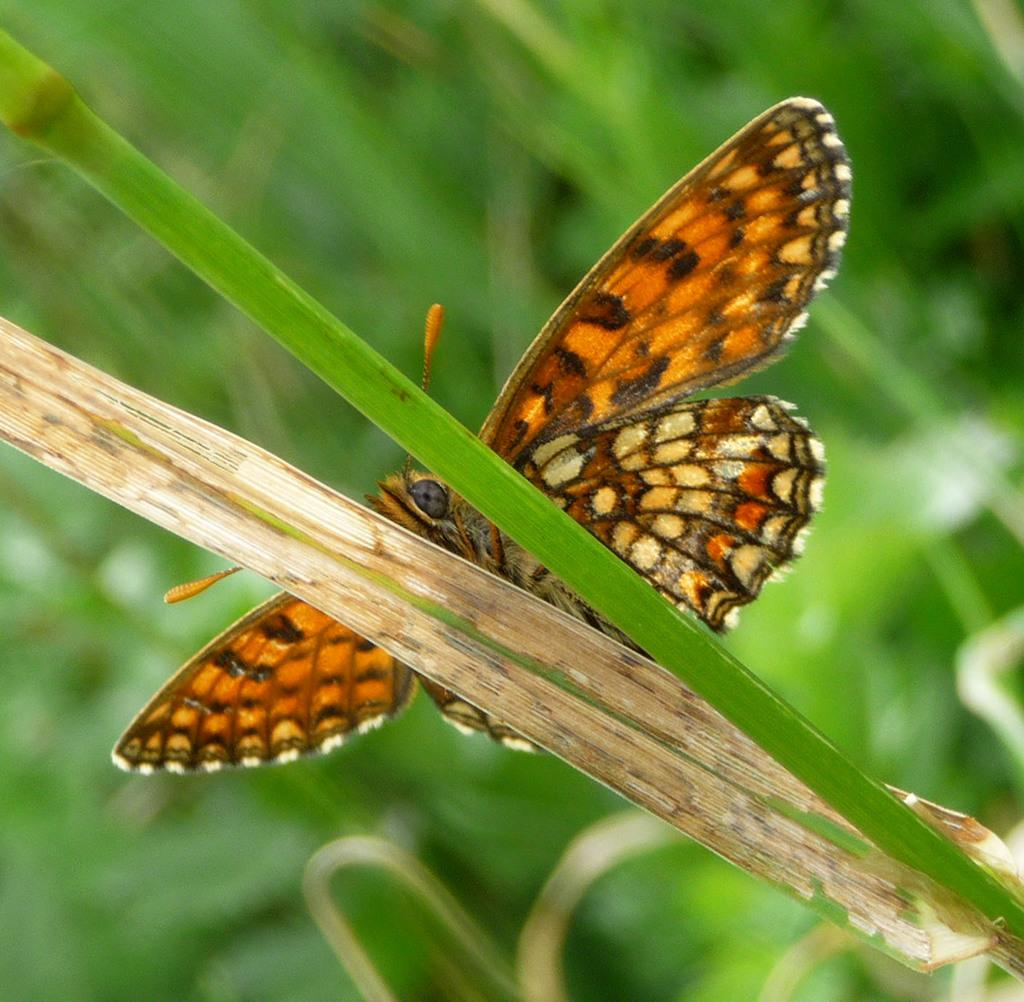What is the main subject of the image? There is a butterfly in the image. Where is the butterfly located in the image? The butterfly is sitting on a leaf. Can you describe the background of the image? The background of the image is blurred. What type of thread is being used to create the scarecrow in the image? There is no scarecrow present in the image, so it is not possible to determine what type of thread might be used. 